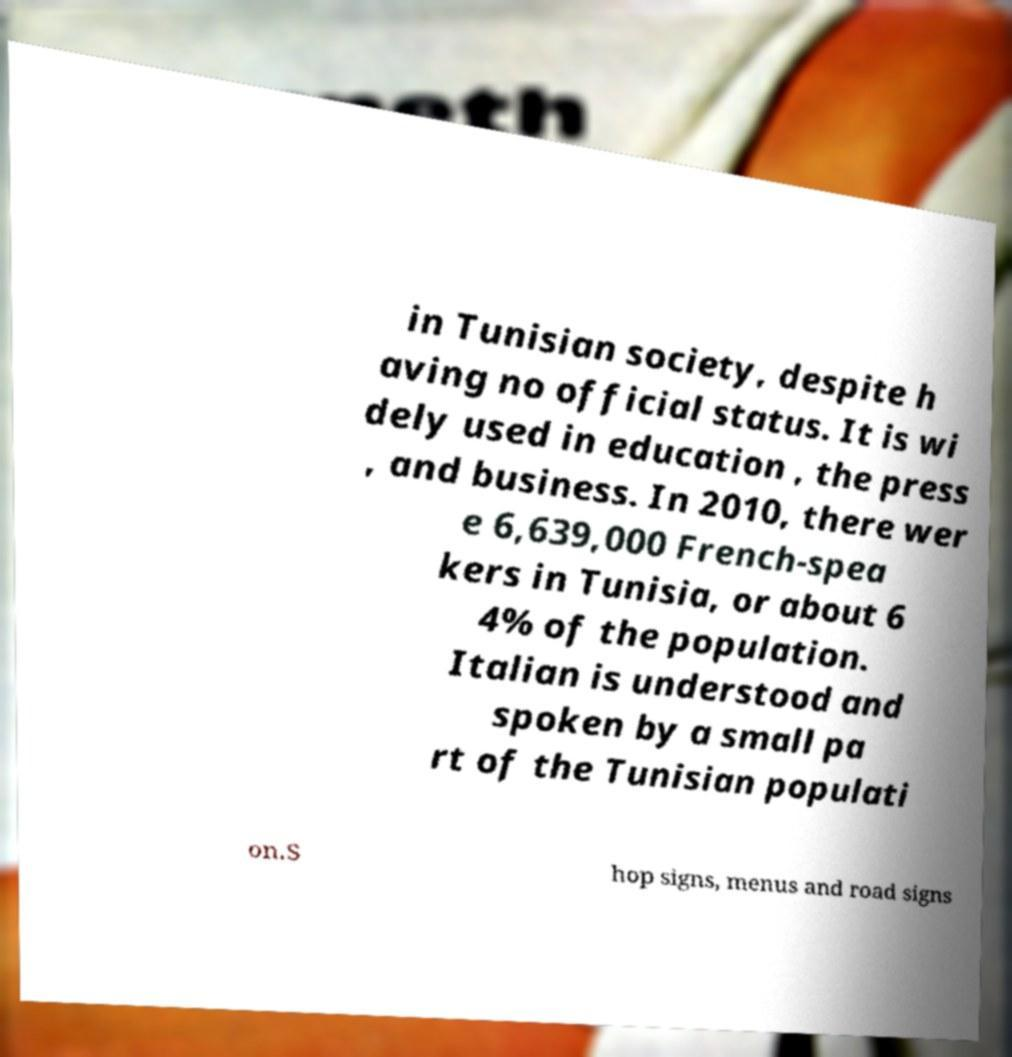I need the written content from this picture converted into text. Can you do that? in Tunisian society, despite h aving no official status. It is wi dely used in education , the press , and business. In 2010, there wer e 6,639,000 French-spea kers in Tunisia, or about 6 4% of the population. Italian is understood and spoken by a small pa rt of the Tunisian populati on.S hop signs, menus and road signs 